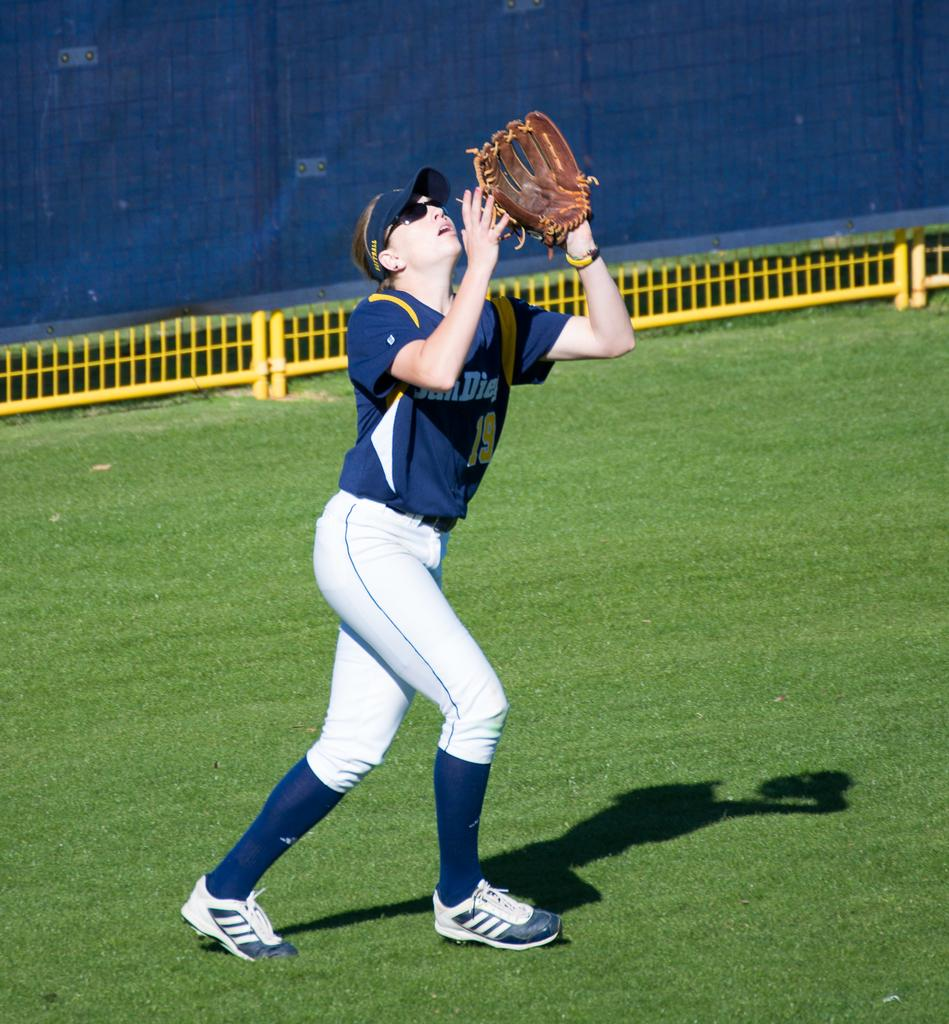<image>
Provide a brief description of the given image. Women softball player about to catch a fly ball in the outfield, her jersey says San Diego # 19. 